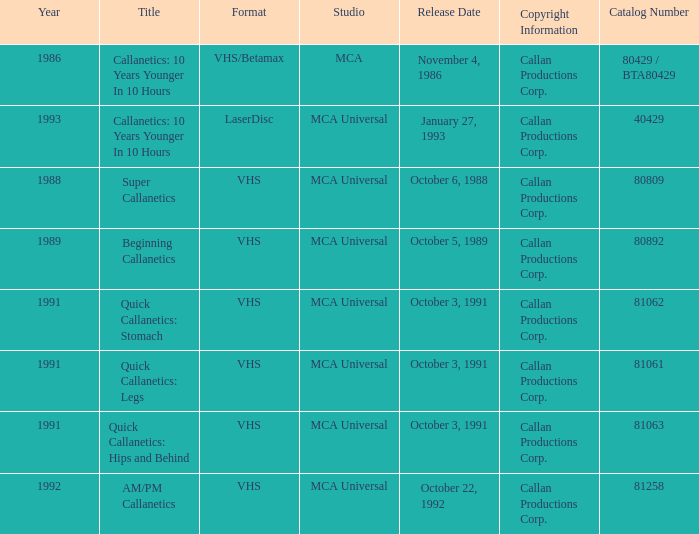Specify the arrangement for super callanetics VHS. 